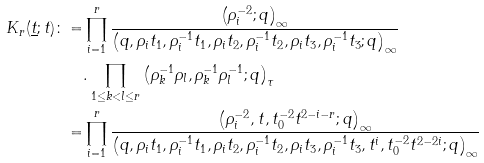<formula> <loc_0><loc_0><loc_500><loc_500>K _ { r } ( \underline { t } ; t ) \colon = & \prod _ { i = 1 } ^ { r } \frac { \left ( \rho _ { i } ^ { - 2 } ; q \right ) _ { \infty } } { \left ( q , \rho _ { i } t _ { 1 } , \rho _ { i } ^ { - 1 } t _ { 1 } , \rho _ { i } t _ { 2 } , \rho _ { i } ^ { - 1 } t _ { 2 } , \rho _ { i } t _ { 3 } , \rho _ { i } ^ { - 1 } t _ { 3 } ; q \right ) _ { \infty } } \\ & . \prod _ { 1 \leq k < l \leq r } \left ( \rho _ { k } ^ { - 1 } \rho _ { l } , \rho _ { k } ^ { - 1 } \rho _ { l } ^ { - 1 } ; q \right ) _ { \tau } \\ = & \prod _ { i = 1 } ^ { r } \frac { \left ( \rho _ { i } ^ { - 2 } , t , t _ { 0 } ^ { - 2 } t ^ { 2 - i - r } ; q \right ) _ { \infty } } { \left ( q , \rho _ { i } t _ { 1 } , \rho _ { i } ^ { - 1 } t _ { 1 } , \rho _ { i } t _ { 2 } , \rho _ { i } ^ { - 1 } t _ { 2 } , \rho _ { i } t _ { 3 } , \rho _ { i } ^ { - 1 } t _ { 3 } , t ^ { i } , t _ { 0 } ^ { - 2 } t ^ { 2 - 2 i } ; q \right ) _ { \infty } }</formula> 